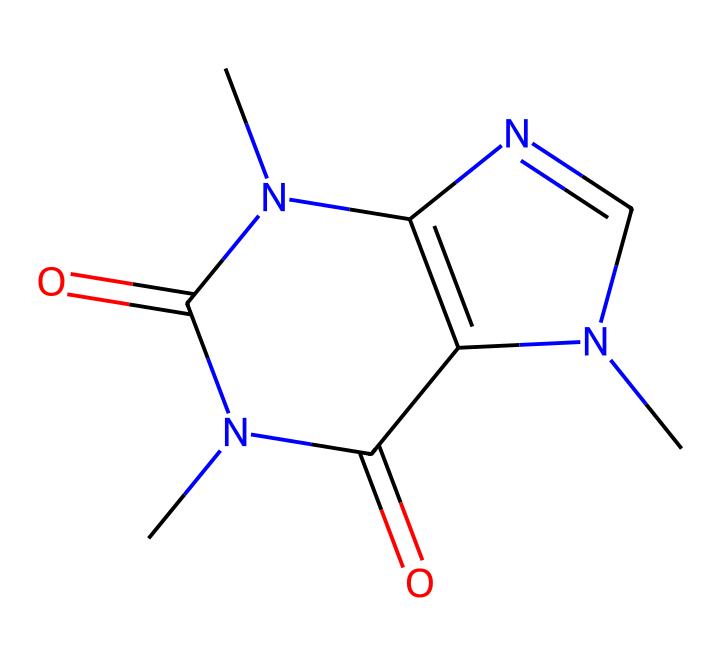What is the molecular formula of caffeine? To find the molecular formula, we count the number of each type of atom in the SMILES representation. The structure contains 8 carbon (C), 10 hydrogen (H), 4 nitrogen (N), and 2 oxygen (O) atoms. Therefore, the molecular formula is C8H10N4O2.
Answer: C8H10N4O2 How many nitrogen atoms are present in the structure? By examining the SMILES, there are 4 nitrogen atoms represented (N), indicated by the letter “N” appearing four times.
Answer: 4 What type of compound is caffeine classified as? Caffeine is classified as an alkaloid due to the presence of multiple nitrogen atoms in its structure, which is characteristic of many alkaloids known for their physiological effects.
Answer: alkaloid What is the total number of rings in caffeine's structure? In the SMILES code, the “N1” and “N2” notation indicates the presence of two interconnected ring structures. Therefore, caffeine has 2 rings.
Answer: 2 Does caffeine have any functional groups? Upon analyzing the structure, we can identify amine (from nitrogen) and carbonyl (C=O) groups within caffeine, confirming that it has functional groups.
Answer: yes What is the potential effect of caffeine on the human body? Caffeine acts as a central nervous system stimulant, promoting alertness and reducing fatigue due to its effect on neurotransmitters, primarily through antagonism of adenosine receptors.
Answer: stimulant 